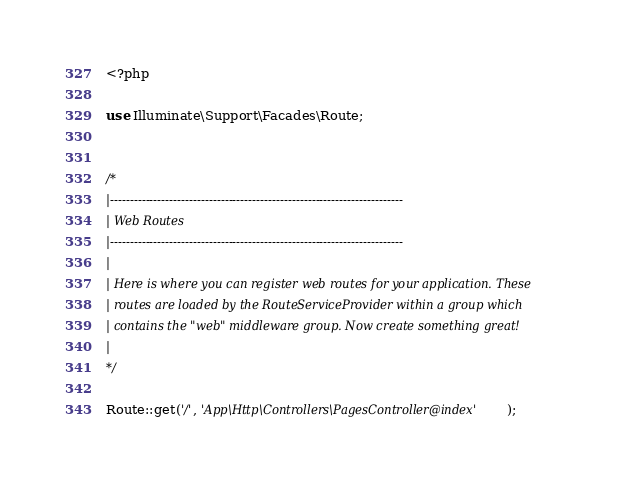Convert code to text. <code><loc_0><loc_0><loc_500><loc_500><_PHP_><?php

use Illuminate\Support\Facades\Route;


/*
|--------------------------------------------------------------------------
| Web Routes
|--------------------------------------------------------------------------
|
| Here is where you can register web routes for your application. These
| routes are loaded by the RouteServiceProvider within a group which
| contains the "web" middleware group. Now create something great!
|
*/

Route::get('/', 'App\Http\Controllers\PagesController@index');
</code> 